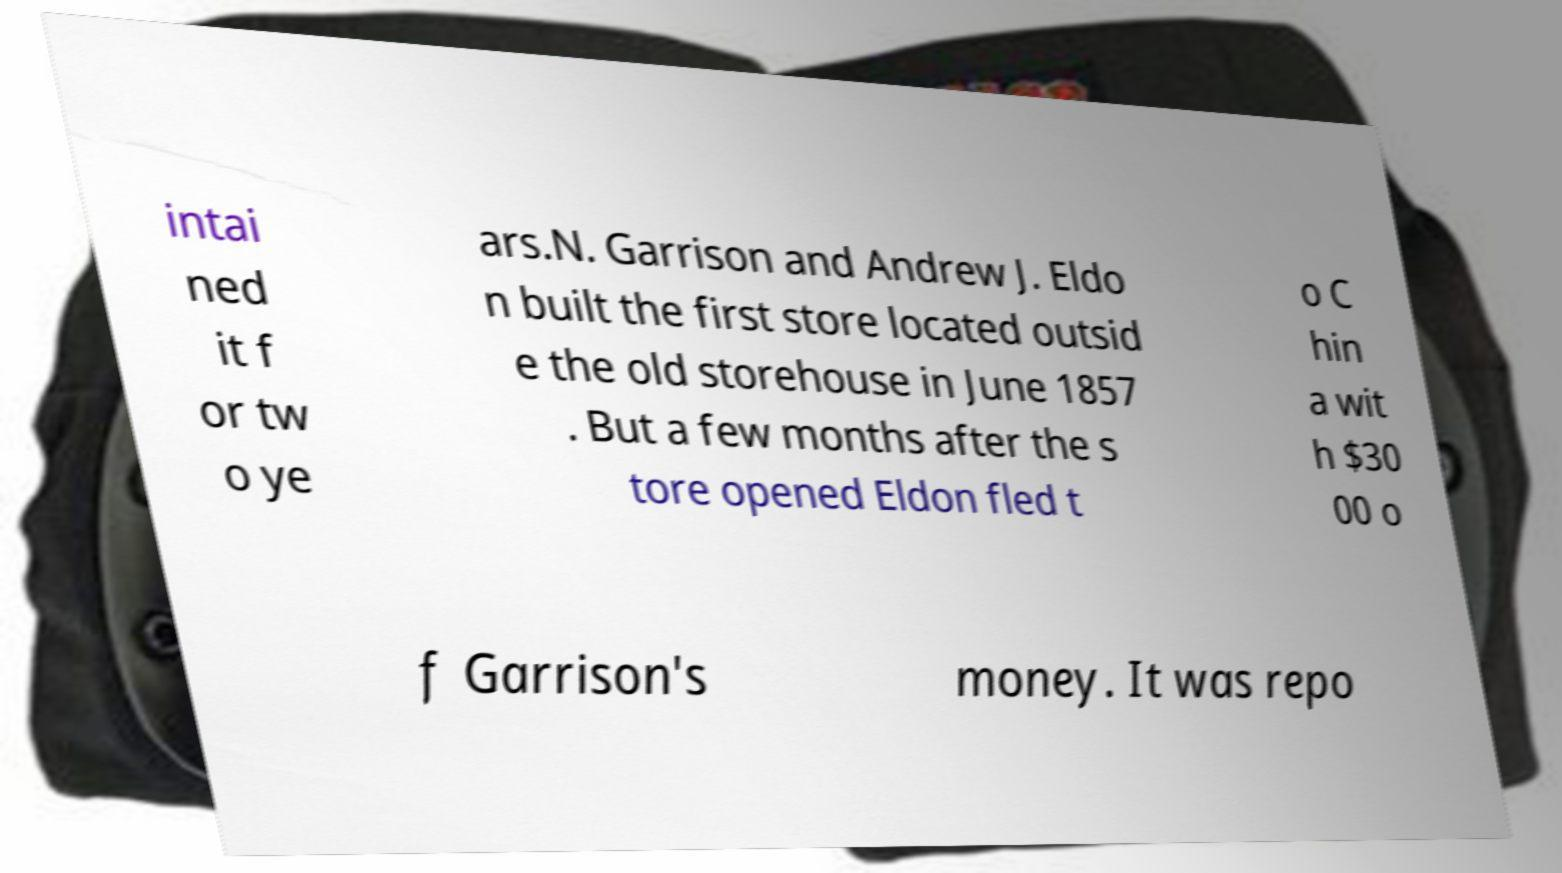What messages or text are displayed in this image? I need them in a readable, typed format. intai ned it f or tw o ye ars.N. Garrison and Andrew J. Eldo n built the first store located outsid e the old storehouse in June 1857 . But a few months after the s tore opened Eldon fled t o C hin a wit h $30 00 o f Garrison's money. It was repo 